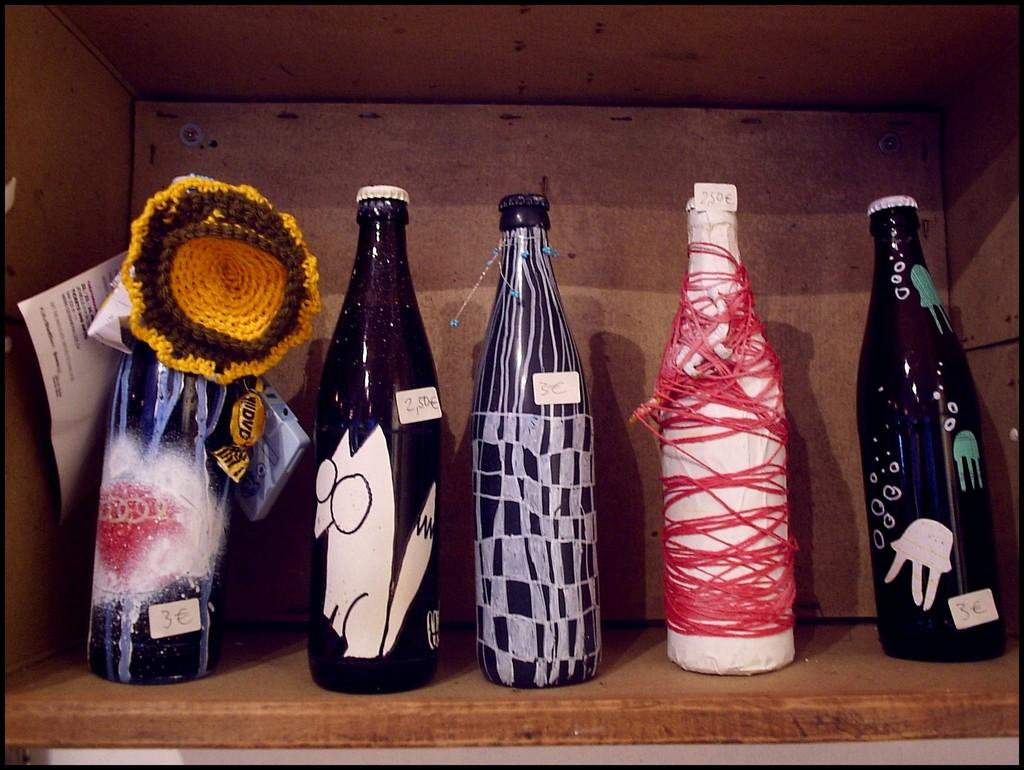What objects can be seen in the image? There are bottles and a paper in a wooden box in the image. Can you describe the bottles in the image? The provided facts do not give any specific details about the bottles, so we cannot describe them further. What is the paper placed in? The paper is placed in a wooden box in the image. How many calculators can be seen on the trail in the image? There is no trail or calculator present in the image. What thoughts are going through the mind of the person who placed the paper in the wooden box? The provided facts do not give any information about the person who placed the paper in the wooden box or their thoughts, so we cannot answer this question. 